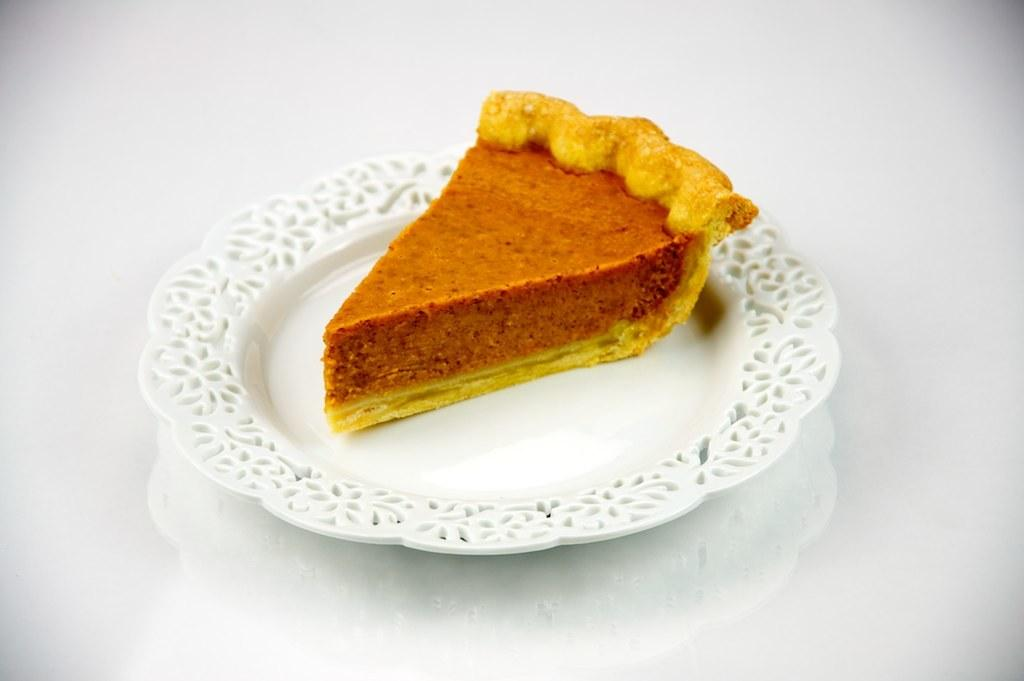What is the main subject of the image? The main subject of the image is a piece of cake. Where is the piece of cake located? The piece of cake is on a plate. What is the plate resting on? The plate is on a table. How many rings are stacked on top of the cake in the image? There are no rings stacked on top of the cake in the image; it only shows a piece of cake on a plate. 